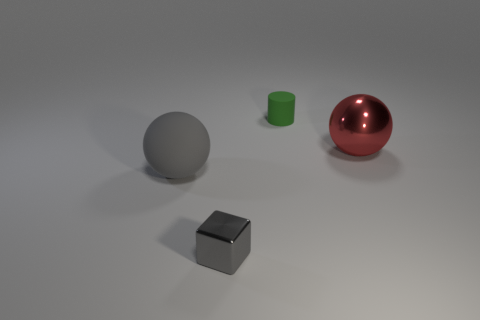Do the metal cube and the matte sphere have the same color?
Offer a terse response. Yes. How many other objects are there of the same shape as the large red thing?
Keep it short and to the point. 1. There is a big red sphere; are there any green rubber cylinders to the right of it?
Your answer should be very brief. No. What is the color of the small rubber object?
Your answer should be compact. Green. There is a block; is it the same color as the large ball that is to the left of the red ball?
Offer a terse response. Yes. Is there a gray object that has the same size as the cylinder?
Offer a very short reply. Yes. What size is the other thing that is the same color as the tiny metal thing?
Offer a terse response. Large. There is a tiny thing that is behind the large gray thing; what is its material?
Provide a succinct answer. Rubber. Are there an equal number of gray spheres on the right side of the big red shiny thing and metal objects that are on the left side of the rubber cylinder?
Your answer should be compact. No. There is a matte thing behind the big red metallic thing; does it have the same size as the shiny thing in front of the big gray rubber thing?
Offer a very short reply. Yes. 